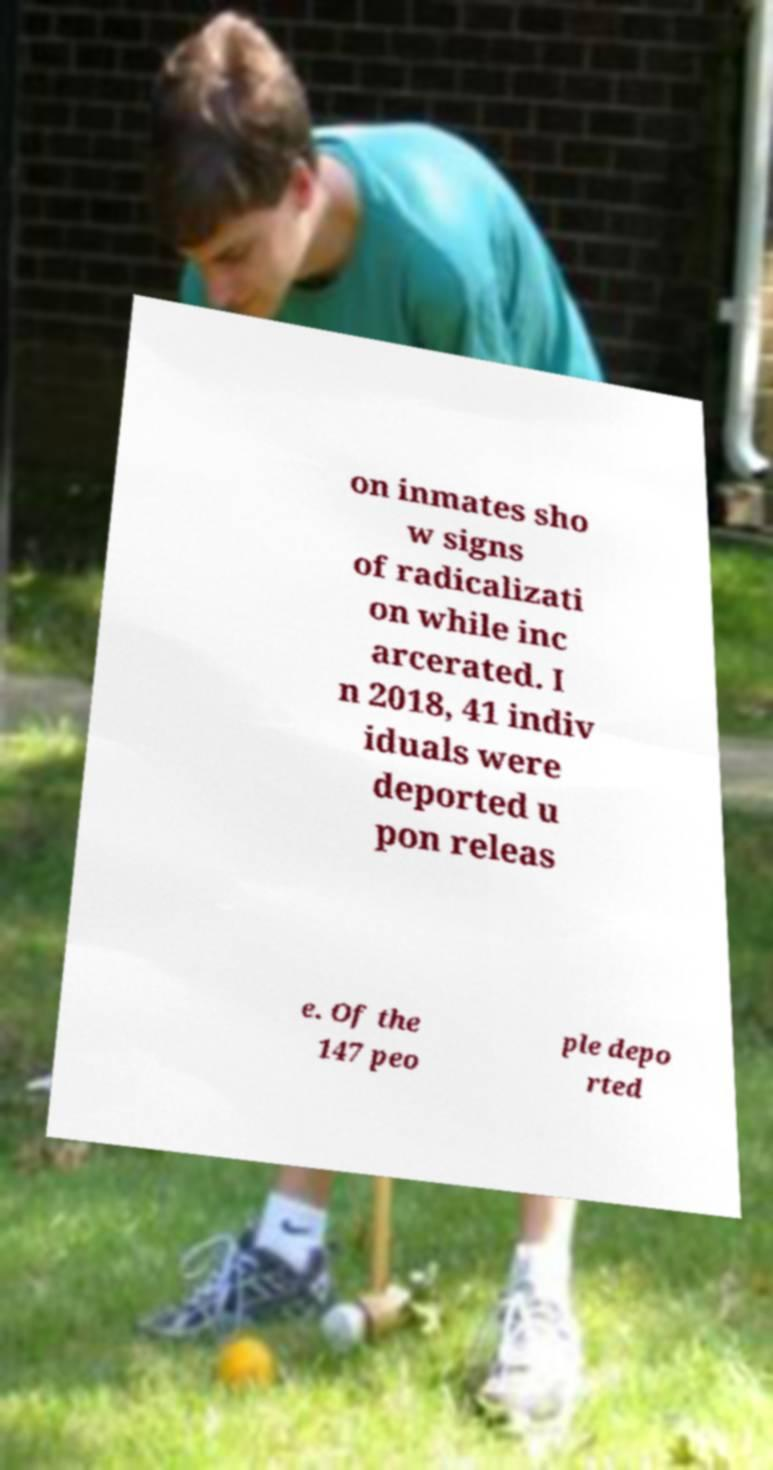Could you assist in decoding the text presented in this image and type it out clearly? on inmates sho w signs of radicalizati on while inc arcerated. I n 2018, 41 indiv iduals were deported u pon releas e. Of the 147 peo ple depo rted 